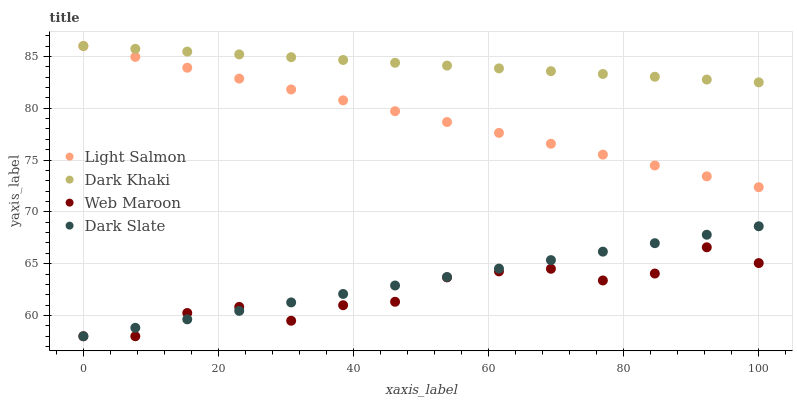Does Web Maroon have the minimum area under the curve?
Answer yes or no. Yes. Does Dark Khaki have the maximum area under the curve?
Answer yes or no. Yes. Does Dark Slate have the minimum area under the curve?
Answer yes or no. No. Does Dark Slate have the maximum area under the curve?
Answer yes or no. No. Is Dark Slate the smoothest?
Answer yes or no. Yes. Is Web Maroon the roughest?
Answer yes or no. Yes. Is Light Salmon the smoothest?
Answer yes or no. No. Is Light Salmon the roughest?
Answer yes or no. No. Does Dark Slate have the lowest value?
Answer yes or no. Yes. Does Light Salmon have the lowest value?
Answer yes or no. No. Does Light Salmon have the highest value?
Answer yes or no. Yes. Does Dark Slate have the highest value?
Answer yes or no. No. Is Dark Slate less than Dark Khaki?
Answer yes or no. Yes. Is Dark Khaki greater than Dark Slate?
Answer yes or no. Yes. Does Dark Khaki intersect Light Salmon?
Answer yes or no. Yes. Is Dark Khaki less than Light Salmon?
Answer yes or no. No. Is Dark Khaki greater than Light Salmon?
Answer yes or no. No. Does Dark Slate intersect Dark Khaki?
Answer yes or no. No. 